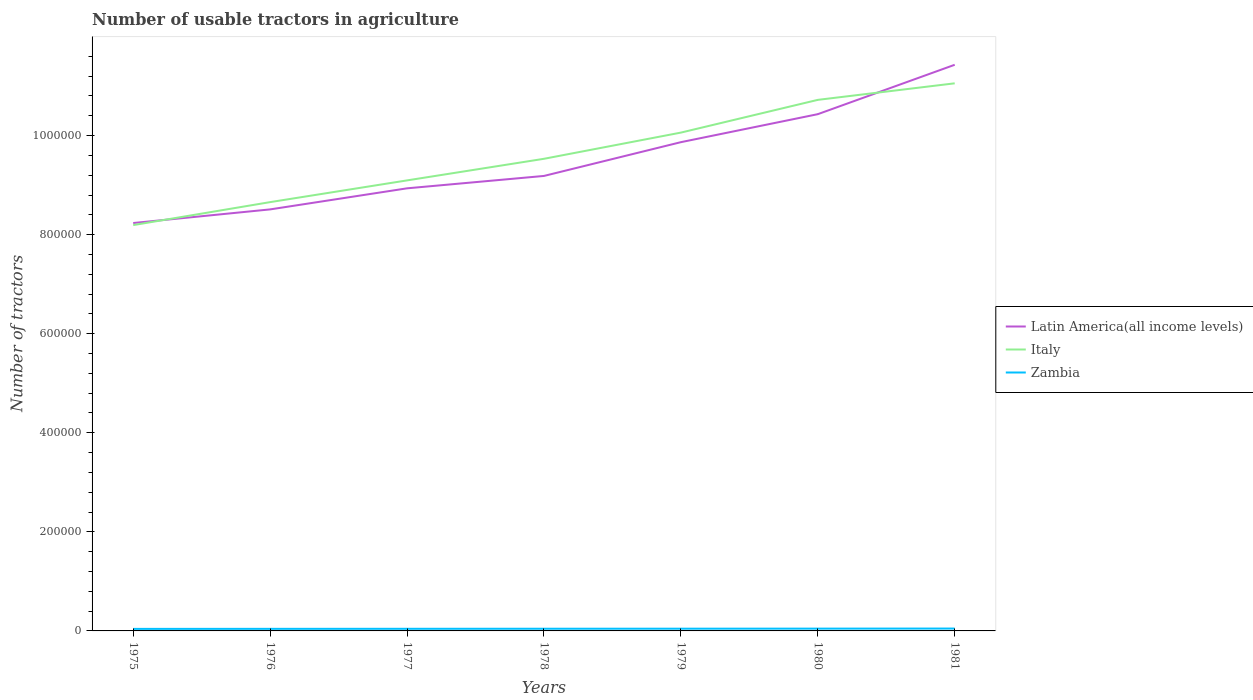Is the number of lines equal to the number of legend labels?
Your response must be concise. Yes. Across all years, what is the maximum number of usable tractors in agriculture in Zambia?
Offer a very short reply. 4100. In which year was the number of usable tractors in agriculture in Italy maximum?
Keep it short and to the point. 1975. What is the total number of usable tractors in agriculture in Italy in the graph?
Your answer should be very brief. -8.75e+04. What is the difference between the highest and the second highest number of usable tractors in agriculture in Latin America(all income levels)?
Make the answer very short. 3.19e+05. How many lines are there?
Your response must be concise. 3. How many years are there in the graph?
Your answer should be very brief. 7. What is the difference between two consecutive major ticks on the Y-axis?
Ensure brevity in your answer.  2.00e+05. Does the graph contain any zero values?
Your response must be concise. No. Does the graph contain grids?
Make the answer very short. No. Where does the legend appear in the graph?
Make the answer very short. Center right. How are the legend labels stacked?
Your answer should be compact. Vertical. What is the title of the graph?
Ensure brevity in your answer.  Number of usable tractors in agriculture. What is the label or title of the X-axis?
Keep it short and to the point. Years. What is the label or title of the Y-axis?
Ensure brevity in your answer.  Number of tractors. What is the Number of tractors in Latin America(all income levels) in 1975?
Offer a very short reply. 8.24e+05. What is the Number of tractors in Italy in 1975?
Offer a terse response. 8.19e+05. What is the Number of tractors in Zambia in 1975?
Your answer should be compact. 4100. What is the Number of tractors in Latin America(all income levels) in 1976?
Give a very brief answer. 8.51e+05. What is the Number of tractors in Italy in 1976?
Your answer should be compact. 8.66e+05. What is the Number of tractors in Zambia in 1976?
Your response must be concise. 4200. What is the Number of tractors in Latin America(all income levels) in 1977?
Offer a very short reply. 8.94e+05. What is the Number of tractors in Italy in 1977?
Keep it short and to the point. 9.10e+05. What is the Number of tractors of Zambia in 1977?
Ensure brevity in your answer.  4300. What is the Number of tractors in Latin America(all income levels) in 1978?
Make the answer very short. 9.19e+05. What is the Number of tractors of Italy in 1978?
Give a very brief answer. 9.53e+05. What is the Number of tractors in Zambia in 1978?
Your response must be concise. 4400. What is the Number of tractors of Latin America(all income levels) in 1979?
Give a very brief answer. 9.87e+05. What is the Number of tractors in Italy in 1979?
Make the answer very short. 1.01e+06. What is the Number of tractors of Zambia in 1979?
Give a very brief answer. 4500. What is the Number of tractors in Latin America(all income levels) in 1980?
Give a very brief answer. 1.04e+06. What is the Number of tractors of Italy in 1980?
Your response must be concise. 1.07e+06. What is the Number of tractors of Zambia in 1980?
Keep it short and to the point. 4640. What is the Number of tractors of Latin America(all income levels) in 1981?
Offer a very short reply. 1.14e+06. What is the Number of tractors of Italy in 1981?
Offer a very short reply. 1.11e+06. What is the Number of tractors of Zambia in 1981?
Your answer should be compact. 4780. Across all years, what is the maximum Number of tractors of Latin America(all income levels)?
Provide a short and direct response. 1.14e+06. Across all years, what is the maximum Number of tractors in Italy?
Keep it short and to the point. 1.11e+06. Across all years, what is the maximum Number of tractors in Zambia?
Your response must be concise. 4780. Across all years, what is the minimum Number of tractors in Latin America(all income levels)?
Your answer should be compact. 8.24e+05. Across all years, what is the minimum Number of tractors of Italy?
Offer a very short reply. 8.19e+05. Across all years, what is the minimum Number of tractors in Zambia?
Provide a succinct answer. 4100. What is the total Number of tractors of Latin America(all income levels) in the graph?
Ensure brevity in your answer.  6.66e+06. What is the total Number of tractors in Italy in the graph?
Offer a very short reply. 6.73e+06. What is the total Number of tractors in Zambia in the graph?
Ensure brevity in your answer.  3.09e+04. What is the difference between the Number of tractors in Latin America(all income levels) in 1975 and that in 1976?
Your answer should be compact. -2.75e+04. What is the difference between the Number of tractors in Italy in 1975 and that in 1976?
Provide a succinct answer. -4.64e+04. What is the difference between the Number of tractors in Zambia in 1975 and that in 1976?
Your response must be concise. -100. What is the difference between the Number of tractors in Latin America(all income levels) in 1975 and that in 1977?
Offer a very short reply. -7.01e+04. What is the difference between the Number of tractors in Italy in 1975 and that in 1977?
Give a very brief answer. -9.02e+04. What is the difference between the Number of tractors in Zambia in 1975 and that in 1977?
Offer a very short reply. -200. What is the difference between the Number of tractors in Latin America(all income levels) in 1975 and that in 1978?
Your answer should be compact. -9.51e+04. What is the difference between the Number of tractors in Italy in 1975 and that in 1978?
Offer a very short reply. -1.34e+05. What is the difference between the Number of tractors in Zambia in 1975 and that in 1978?
Provide a short and direct response. -300. What is the difference between the Number of tractors of Latin America(all income levels) in 1975 and that in 1979?
Keep it short and to the point. -1.63e+05. What is the difference between the Number of tractors in Italy in 1975 and that in 1979?
Provide a succinct answer. -1.87e+05. What is the difference between the Number of tractors of Zambia in 1975 and that in 1979?
Keep it short and to the point. -400. What is the difference between the Number of tractors of Latin America(all income levels) in 1975 and that in 1980?
Offer a terse response. -2.20e+05. What is the difference between the Number of tractors in Italy in 1975 and that in 1980?
Give a very brief answer. -2.53e+05. What is the difference between the Number of tractors of Zambia in 1975 and that in 1980?
Provide a short and direct response. -540. What is the difference between the Number of tractors of Latin America(all income levels) in 1975 and that in 1981?
Give a very brief answer. -3.19e+05. What is the difference between the Number of tractors of Italy in 1975 and that in 1981?
Make the answer very short. -2.86e+05. What is the difference between the Number of tractors of Zambia in 1975 and that in 1981?
Offer a very short reply. -680. What is the difference between the Number of tractors of Latin America(all income levels) in 1976 and that in 1977?
Ensure brevity in your answer.  -4.25e+04. What is the difference between the Number of tractors of Italy in 1976 and that in 1977?
Your answer should be very brief. -4.39e+04. What is the difference between the Number of tractors of Zambia in 1976 and that in 1977?
Offer a terse response. -100. What is the difference between the Number of tractors of Latin America(all income levels) in 1976 and that in 1978?
Provide a short and direct response. -6.76e+04. What is the difference between the Number of tractors of Italy in 1976 and that in 1978?
Ensure brevity in your answer.  -8.75e+04. What is the difference between the Number of tractors in Zambia in 1976 and that in 1978?
Your answer should be compact. -200. What is the difference between the Number of tractors in Latin America(all income levels) in 1976 and that in 1979?
Give a very brief answer. -1.36e+05. What is the difference between the Number of tractors of Italy in 1976 and that in 1979?
Provide a short and direct response. -1.40e+05. What is the difference between the Number of tractors of Zambia in 1976 and that in 1979?
Provide a short and direct response. -300. What is the difference between the Number of tractors of Latin America(all income levels) in 1976 and that in 1980?
Offer a very short reply. -1.92e+05. What is the difference between the Number of tractors of Italy in 1976 and that in 1980?
Your answer should be very brief. -2.06e+05. What is the difference between the Number of tractors in Zambia in 1976 and that in 1980?
Give a very brief answer. -440. What is the difference between the Number of tractors in Latin America(all income levels) in 1976 and that in 1981?
Give a very brief answer. -2.92e+05. What is the difference between the Number of tractors in Italy in 1976 and that in 1981?
Make the answer very short. -2.40e+05. What is the difference between the Number of tractors in Zambia in 1976 and that in 1981?
Keep it short and to the point. -580. What is the difference between the Number of tractors in Latin America(all income levels) in 1977 and that in 1978?
Offer a terse response. -2.50e+04. What is the difference between the Number of tractors in Italy in 1977 and that in 1978?
Offer a very short reply. -4.36e+04. What is the difference between the Number of tractors in Zambia in 1977 and that in 1978?
Offer a very short reply. -100. What is the difference between the Number of tractors in Latin America(all income levels) in 1977 and that in 1979?
Offer a terse response. -9.32e+04. What is the difference between the Number of tractors in Italy in 1977 and that in 1979?
Provide a succinct answer. -9.65e+04. What is the difference between the Number of tractors of Zambia in 1977 and that in 1979?
Your answer should be compact. -200. What is the difference between the Number of tractors in Latin America(all income levels) in 1977 and that in 1980?
Your response must be concise. -1.50e+05. What is the difference between the Number of tractors in Italy in 1977 and that in 1980?
Your answer should be very brief. -1.63e+05. What is the difference between the Number of tractors of Zambia in 1977 and that in 1980?
Offer a terse response. -340. What is the difference between the Number of tractors in Latin America(all income levels) in 1977 and that in 1981?
Keep it short and to the point. -2.49e+05. What is the difference between the Number of tractors in Italy in 1977 and that in 1981?
Your response must be concise. -1.96e+05. What is the difference between the Number of tractors of Zambia in 1977 and that in 1981?
Offer a terse response. -480. What is the difference between the Number of tractors in Latin America(all income levels) in 1978 and that in 1979?
Your response must be concise. -6.82e+04. What is the difference between the Number of tractors in Italy in 1978 and that in 1979?
Your answer should be very brief. -5.29e+04. What is the difference between the Number of tractors of Zambia in 1978 and that in 1979?
Your response must be concise. -100. What is the difference between the Number of tractors of Latin America(all income levels) in 1978 and that in 1980?
Keep it short and to the point. -1.25e+05. What is the difference between the Number of tractors of Italy in 1978 and that in 1980?
Give a very brief answer. -1.19e+05. What is the difference between the Number of tractors in Zambia in 1978 and that in 1980?
Offer a terse response. -240. What is the difference between the Number of tractors of Latin America(all income levels) in 1978 and that in 1981?
Your answer should be compact. -2.24e+05. What is the difference between the Number of tractors of Italy in 1978 and that in 1981?
Offer a very short reply. -1.52e+05. What is the difference between the Number of tractors of Zambia in 1978 and that in 1981?
Offer a very short reply. -380. What is the difference between the Number of tractors of Latin America(all income levels) in 1979 and that in 1980?
Your response must be concise. -5.65e+04. What is the difference between the Number of tractors in Italy in 1979 and that in 1980?
Your response must be concise. -6.61e+04. What is the difference between the Number of tractors in Zambia in 1979 and that in 1980?
Your response must be concise. -140. What is the difference between the Number of tractors of Latin America(all income levels) in 1979 and that in 1981?
Ensure brevity in your answer.  -1.56e+05. What is the difference between the Number of tractors of Italy in 1979 and that in 1981?
Offer a very short reply. -9.95e+04. What is the difference between the Number of tractors in Zambia in 1979 and that in 1981?
Offer a terse response. -280. What is the difference between the Number of tractors of Latin America(all income levels) in 1980 and that in 1981?
Make the answer very short. -9.97e+04. What is the difference between the Number of tractors of Italy in 1980 and that in 1981?
Keep it short and to the point. -3.34e+04. What is the difference between the Number of tractors in Zambia in 1980 and that in 1981?
Your response must be concise. -140. What is the difference between the Number of tractors of Latin America(all income levels) in 1975 and the Number of tractors of Italy in 1976?
Keep it short and to the point. -4.22e+04. What is the difference between the Number of tractors of Latin America(all income levels) in 1975 and the Number of tractors of Zambia in 1976?
Provide a short and direct response. 8.19e+05. What is the difference between the Number of tractors in Italy in 1975 and the Number of tractors in Zambia in 1976?
Keep it short and to the point. 8.15e+05. What is the difference between the Number of tractors in Latin America(all income levels) in 1975 and the Number of tractors in Italy in 1977?
Provide a short and direct response. -8.61e+04. What is the difference between the Number of tractors of Latin America(all income levels) in 1975 and the Number of tractors of Zambia in 1977?
Keep it short and to the point. 8.19e+05. What is the difference between the Number of tractors of Italy in 1975 and the Number of tractors of Zambia in 1977?
Ensure brevity in your answer.  8.15e+05. What is the difference between the Number of tractors in Latin America(all income levels) in 1975 and the Number of tractors in Italy in 1978?
Offer a terse response. -1.30e+05. What is the difference between the Number of tractors of Latin America(all income levels) in 1975 and the Number of tractors of Zambia in 1978?
Make the answer very short. 8.19e+05. What is the difference between the Number of tractors in Italy in 1975 and the Number of tractors in Zambia in 1978?
Offer a very short reply. 8.15e+05. What is the difference between the Number of tractors in Latin America(all income levels) in 1975 and the Number of tractors in Italy in 1979?
Offer a very short reply. -1.83e+05. What is the difference between the Number of tractors in Latin America(all income levels) in 1975 and the Number of tractors in Zambia in 1979?
Your answer should be very brief. 8.19e+05. What is the difference between the Number of tractors of Italy in 1975 and the Number of tractors of Zambia in 1979?
Offer a terse response. 8.15e+05. What is the difference between the Number of tractors of Latin America(all income levels) in 1975 and the Number of tractors of Italy in 1980?
Offer a terse response. -2.49e+05. What is the difference between the Number of tractors in Latin America(all income levels) in 1975 and the Number of tractors in Zambia in 1980?
Keep it short and to the point. 8.19e+05. What is the difference between the Number of tractors in Italy in 1975 and the Number of tractors in Zambia in 1980?
Offer a terse response. 8.15e+05. What is the difference between the Number of tractors in Latin America(all income levels) in 1975 and the Number of tractors in Italy in 1981?
Provide a short and direct response. -2.82e+05. What is the difference between the Number of tractors in Latin America(all income levels) in 1975 and the Number of tractors in Zambia in 1981?
Provide a short and direct response. 8.19e+05. What is the difference between the Number of tractors of Italy in 1975 and the Number of tractors of Zambia in 1981?
Keep it short and to the point. 8.15e+05. What is the difference between the Number of tractors in Latin America(all income levels) in 1976 and the Number of tractors in Italy in 1977?
Your response must be concise. -5.85e+04. What is the difference between the Number of tractors of Latin America(all income levels) in 1976 and the Number of tractors of Zambia in 1977?
Keep it short and to the point. 8.47e+05. What is the difference between the Number of tractors in Italy in 1976 and the Number of tractors in Zambia in 1977?
Provide a succinct answer. 8.61e+05. What is the difference between the Number of tractors in Latin America(all income levels) in 1976 and the Number of tractors in Italy in 1978?
Your response must be concise. -1.02e+05. What is the difference between the Number of tractors of Latin America(all income levels) in 1976 and the Number of tractors of Zambia in 1978?
Give a very brief answer. 8.47e+05. What is the difference between the Number of tractors of Italy in 1976 and the Number of tractors of Zambia in 1978?
Make the answer very short. 8.61e+05. What is the difference between the Number of tractors of Latin America(all income levels) in 1976 and the Number of tractors of Italy in 1979?
Provide a short and direct response. -1.55e+05. What is the difference between the Number of tractors of Latin America(all income levels) in 1976 and the Number of tractors of Zambia in 1979?
Ensure brevity in your answer.  8.47e+05. What is the difference between the Number of tractors in Italy in 1976 and the Number of tractors in Zambia in 1979?
Offer a very short reply. 8.61e+05. What is the difference between the Number of tractors in Latin America(all income levels) in 1976 and the Number of tractors in Italy in 1980?
Keep it short and to the point. -2.21e+05. What is the difference between the Number of tractors in Latin America(all income levels) in 1976 and the Number of tractors in Zambia in 1980?
Give a very brief answer. 8.46e+05. What is the difference between the Number of tractors of Italy in 1976 and the Number of tractors of Zambia in 1980?
Make the answer very short. 8.61e+05. What is the difference between the Number of tractors in Latin America(all income levels) in 1976 and the Number of tractors in Italy in 1981?
Your response must be concise. -2.55e+05. What is the difference between the Number of tractors in Latin America(all income levels) in 1976 and the Number of tractors in Zambia in 1981?
Your answer should be very brief. 8.46e+05. What is the difference between the Number of tractors in Italy in 1976 and the Number of tractors in Zambia in 1981?
Provide a short and direct response. 8.61e+05. What is the difference between the Number of tractors in Latin America(all income levels) in 1977 and the Number of tractors in Italy in 1978?
Make the answer very short. -5.96e+04. What is the difference between the Number of tractors of Latin America(all income levels) in 1977 and the Number of tractors of Zambia in 1978?
Your answer should be very brief. 8.89e+05. What is the difference between the Number of tractors of Italy in 1977 and the Number of tractors of Zambia in 1978?
Keep it short and to the point. 9.05e+05. What is the difference between the Number of tractors of Latin America(all income levels) in 1977 and the Number of tractors of Italy in 1979?
Give a very brief answer. -1.13e+05. What is the difference between the Number of tractors in Latin America(all income levels) in 1977 and the Number of tractors in Zambia in 1979?
Give a very brief answer. 8.89e+05. What is the difference between the Number of tractors in Italy in 1977 and the Number of tractors in Zambia in 1979?
Ensure brevity in your answer.  9.05e+05. What is the difference between the Number of tractors in Latin America(all income levels) in 1977 and the Number of tractors in Italy in 1980?
Keep it short and to the point. -1.79e+05. What is the difference between the Number of tractors of Latin America(all income levels) in 1977 and the Number of tractors of Zambia in 1980?
Your answer should be very brief. 8.89e+05. What is the difference between the Number of tractors of Italy in 1977 and the Number of tractors of Zambia in 1980?
Ensure brevity in your answer.  9.05e+05. What is the difference between the Number of tractors of Latin America(all income levels) in 1977 and the Number of tractors of Italy in 1981?
Provide a short and direct response. -2.12e+05. What is the difference between the Number of tractors in Latin America(all income levels) in 1977 and the Number of tractors in Zambia in 1981?
Your answer should be compact. 8.89e+05. What is the difference between the Number of tractors of Italy in 1977 and the Number of tractors of Zambia in 1981?
Keep it short and to the point. 9.05e+05. What is the difference between the Number of tractors of Latin America(all income levels) in 1978 and the Number of tractors of Italy in 1979?
Provide a short and direct response. -8.75e+04. What is the difference between the Number of tractors of Latin America(all income levels) in 1978 and the Number of tractors of Zambia in 1979?
Your answer should be compact. 9.14e+05. What is the difference between the Number of tractors in Italy in 1978 and the Number of tractors in Zambia in 1979?
Provide a short and direct response. 9.49e+05. What is the difference between the Number of tractors of Latin America(all income levels) in 1978 and the Number of tractors of Italy in 1980?
Your answer should be compact. -1.54e+05. What is the difference between the Number of tractors of Latin America(all income levels) in 1978 and the Number of tractors of Zambia in 1980?
Your answer should be compact. 9.14e+05. What is the difference between the Number of tractors of Italy in 1978 and the Number of tractors of Zambia in 1980?
Ensure brevity in your answer.  9.49e+05. What is the difference between the Number of tractors of Latin America(all income levels) in 1978 and the Number of tractors of Italy in 1981?
Give a very brief answer. -1.87e+05. What is the difference between the Number of tractors in Latin America(all income levels) in 1978 and the Number of tractors in Zambia in 1981?
Offer a terse response. 9.14e+05. What is the difference between the Number of tractors of Italy in 1978 and the Number of tractors of Zambia in 1981?
Your answer should be compact. 9.48e+05. What is the difference between the Number of tractors of Latin America(all income levels) in 1979 and the Number of tractors of Italy in 1980?
Your response must be concise. -8.54e+04. What is the difference between the Number of tractors in Latin America(all income levels) in 1979 and the Number of tractors in Zambia in 1980?
Keep it short and to the point. 9.82e+05. What is the difference between the Number of tractors in Italy in 1979 and the Number of tractors in Zambia in 1980?
Make the answer very short. 1.00e+06. What is the difference between the Number of tractors of Latin America(all income levels) in 1979 and the Number of tractors of Italy in 1981?
Ensure brevity in your answer.  -1.19e+05. What is the difference between the Number of tractors in Latin America(all income levels) in 1979 and the Number of tractors in Zambia in 1981?
Provide a short and direct response. 9.82e+05. What is the difference between the Number of tractors in Italy in 1979 and the Number of tractors in Zambia in 1981?
Make the answer very short. 1.00e+06. What is the difference between the Number of tractors of Latin America(all income levels) in 1980 and the Number of tractors of Italy in 1981?
Offer a very short reply. -6.23e+04. What is the difference between the Number of tractors in Latin America(all income levels) in 1980 and the Number of tractors in Zambia in 1981?
Offer a terse response. 1.04e+06. What is the difference between the Number of tractors of Italy in 1980 and the Number of tractors of Zambia in 1981?
Offer a very short reply. 1.07e+06. What is the average Number of tractors of Latin America(all income levels) per year?
Your answer should be very brief. 9.51e+05. What is the average Number of tractors in Italy per year?
Your answer should be compact. 9.62e+05. What is the average Number of tractors of Zambia per year?
Offer a terse response. 4417.14. In the year 1975, what is the difference between the Number of tractors in Latin America(all income levels) and Number of tractors in Italy?
Offer a terse response. 4179. In the year 1975, what is the difference between the Number of tractors in Latin America(all income levels) and Number of tractors in Zambia?
Your response must be concise. 8.19e+05. In the year 1975, what is the difference between the Number of tractors of Italy and Number of tractors of Zambia?
Ensure brevity in your answer.  8.15e+05. In the year 1976, what is the difference between the Number of tractors in Latin America(all income levels) and Number of tractors in Italy?
Offer a very short reply. -1.47e+04. In the year 1976, what is the difference between the Number of tractors in Latin America(all income levels) and Number of tractors in Zambia?
Make the answer very short. 8.47e+05. In the year 1976, what is the difference between the Number of tractors of Italy and Number of tractors of Zambia?
Give a very brief answer. 8.62e+05. In the year 1977, what is the difference between the Number of tractors in Latin America(all income levels) and Number of tractors in Italy?
Your answer should be very brief. -1.60e+04. In the year 1977, what is the difference between the Number of tractors in Latin America(all income levels) and Number of tractors in Zambia?
Your answer should be very brief. 8.89e+05. In the year 1977, what is the difference between the Number of tractors in Italy and Number of tractors in Zambia?
Provide a succinct answer. 9.05e+05. In the year 1978, what is the difference between the Number of tractors in Latin America(all income levels) and Number of tractors in Italy?
Ensure brevity in your answer.  -3.46e+04. In the year 1978, what is the difference between the Number of tractors of Latin America(all income levels) and Number of tractors of Zambia?
Provide a short and direct response. 9.14e+05. In the year 1978, what is the difference between the Number of tractors of Italy and Number of tractors of Zambia?
Provide a short and direct response. 9.49e+05. In the year 1979, what is the difference between the Number of tractors in Latin America(all income levels) and Number of tractors in Italy?
Provide a short and direct response. -1.93e+04. In the year 1979, what is the difference between the Number of tractors of Latin America(all income levels) and Number of tractors of Zambia?
Offer a terse response. 9.82e+05. In the year 1979, what is the difference between the Number of tractors in Italy and Number of tractors in Zambia?
Offer a terse response. 1.00e+06. In the year 1980, what is the difference between the Number of tractors in Latin America(all income levels) and Number of tractors in Italy?
Offer a very short reply. -2.89e+04. In the year 1980, what is the difference between the Number of tractors in Latin America(all income levels) and Number of tractors in Zambia?
Keep it short and to the point. 1.04e+06. In the year 1980, what is the difference between the Number of tractors in Italy and Number of tractors in Zambia?
Offer a terse response. 1.07e+06. In the year 1981, what is the difference between the Number of tractors in Latin America(all income levels) and Number of tractors in Italy?
Provide a short and direct response. 3.74e+04. In the year 1981, what is the difference between the Number of tractors in Latin America(all income levels) and Number of tractors in Zambia?
Ensure brevity in your answer.  1.14e+06. In the year 1981, what is the difference between the Number of tractors of Italy and Number of tractors of Zambia?
Your answer should be compact. 1.10e+06. What is the ratio of the Number of tractors in Italy in 1975 to that in 1976?
Ensure brevity in your answer.  0.95. What is the ratio of the Number of tractors of Zambia in 1975 to that in 1976?
Your answer should be compact. 0.98. What is the ratio of the Number of tractors of Latin America(all income levels) in 1975 to that in 1977?
Ensure brevity in your answer.  0.92. What is the ratio of the Number of tractors of Italy in 1975 to that in 1977?
Your answer should be very brief. 0.9. What is the ratio of the Number of tractors in Zambia in 1975 to that in 1977?
Give a very brief answer. 0.95. What is the ratio of the Number of tractors of Latin America(all income levels) in 1975 to that in 1978?
Give a very brief answer. 0.9. What is the ratio of the Number of tractors of Italy in 1975 to that in 1978?
Make the answer very short. 0.86. What is the ratio of the Number of tractors in Zambia in 1975 to that in 1978?
Offer a terse response. 0.93. What is the ratio of the Number of tractors in Latin America(all income levels) in 1975 to that in 1979?
Provide a succinct answer. 0.83. What is the ratio of the Number of tractors of Italy in 1975 to that in 1979?
Keep it short and to the point. 0.81. What is the ratio of the Number of tractors of Zambia in 1975 to that in 1979?
Give a very brief answer. 0.91. What is the ratio of the Number of tractors of Latin America(all income levels) in 1975 to that in 1980?
Your answer should be compact. 0.79. What is the ratio of the Number of tractors of Italy in 1975 to that in 1980?
Make the answer very short. 0.76. What is the ratio of the Number of tractors in Zambia in 1975 to that in 1980?
Your response must be concise. 0.88. What is the ratio of the Number of tractors in Latin America(all income levels) in 1975 to that in 1981?
Your response must be concise. 0.72. What is the ratio of the Number of tractors of Italy in 1975 to that in 1981?
Provide a short and direct response. 0.74. What is the ratio of the Number of tractors of Zambia in 1975 to that in 1981?
Provide a succinct answer. 0.86. What is the ratio of the Number of tractors in Latin America(all income levels) in 1976 to that in 1977?
Keep it short and to the point. 0.95. What is the ratio of the Number of tractors of Italy in 1976 to that in 1977?
Provide a short and direct response. 0.95. What is the ratio of the Number of tractors in Zambia in 1976 to that in 1977?
Your answer should be compact. 0.98. What is the ratio of the Number of tractors in Latin America(all income levels) in 1976 to that in 1978?
Offer a very short reply. 0.93. What is the ratio of the Number of tractors in Italy in 1976 to that in 1978?
Offer a very short reply. 0.91. What is the ratio of the Number of tractors of Zambia in 1976 to that in 1978?
Offer a very short reply. 0.95. What is the ratio of the Number of tractors in Latin America(all income levels) in 1976 to that in 1979?
Provide a succinct answer. 0.86. What is the ratio of the Number of tractors of Italy in 1976 to that in 1979?
Provide a succinct answer. 0.86. What is the ratio of the Number of tractors in Zambia in 1976 to that in 1979?
Keep it short and to the point. 0.93. What is the ratio of the Number of tractors in Latin America(all income levels) in 1976 to that in 1980?
Your answer should be very brief. 0.82. What is the ratio of the Number of tractors of Italy in 1976 to that in 1980?
Provide a short and direct response. 0.81. What is the ratio of the Number of tractors in Zambia in 1976 to that in 1980?
Your answer should be very brief. 0.91. What is the ratio of the Number of tractors in Latin America(all income levels) in 1976 to that in 1981?
Give a very brief answer. 0.74. What is the ratio of the Number of tractors of Italy in 1976 to that in 1981?
Offer a very short reply. 0.78. What is the ratio of the Number of tractors in Zambia in 1976 to that in 1981?
Your answer should be very brief. 0.88. What is the ratio of the Number of tractors in Latin America(all income levels) in 1977 to that in 1978?
Your answer should be compact. 0.97. What is the ratio of the Number of tractors in Italy in 1977 to that in 1978?
Your answer should be very brief. 0.95. What is the ratio of the Number of tractors of Zambia in 1977 to that in 1978?
Your response must be concise. 0.98. What is the ratio of the Number of tractors in Latin America(all income levels) in 1977 to that in 1979?
Ensure brevity in your answer.  0.91. What is the ratio of the Number of tractors in Italy in 1977 to that in 1979?
Your answer should be compact. 0.9. What is the ratio of the Number of tractors of Zambia in 1977 to that in 1979?
Ensure brevity in your answer.  0.96. What is the ratio of the Number of tractors in Latin America(all income levels) in 1977 to that in 1980?
Offer a terse response. 0.86. What is the ratio of the Number of tractors in Italy in 1977 to that in 1980?
Your answer should be very brief. 0.85. What is the ratio of the Number of tractors in Zambia in 1977 to that in 1980?
Provide a short and direct response. 0.93. What is the ratio of the Number of tractors of Latin America(all income levels) in 1977 to that in 1981?
Your response must be concise. 0.78. What is the ratio of the Number of tractors in Italy in 1977 to that in 1981?
Give a very brief answer. 0.82. What is the ratio of the Number of tractors of Zambia in 1977 to that in 1981?
Give a very brief answer. 0.9. What is the ratio of the Number of tractors of Latin America(all income levels) in 1978 to that in 1979?
Keep it short and to the point. 0.93. What is the ratio of the Number of tractors of Italy in 1978 to that in 1979?
Make the answer very short. 0.95. What is the ratio of the Number of tractors of Zambia in 1978 to that in 1979?
Your response must be concise. 0.98. What is the ratio of the Number of tractors of Latin America(all income levels) in 1978 to that in 1980?
Make the answer very short. 0.88. What is the ratio of the Number of tractors of Italy in 1978 to that in 1980?
Provide a succinct answer. 0.89. What is the ratio of the Number of tractors of Zambia in 1978 to that in 1980?
Make the answer very short. 0.95. What is the ratio of the Number of tractors in Latin America(all income levels) in 1978 to that in 1981?
Ensure brevity in your answer.  0.8. What is the ratio of the Number of tractors of Italy in 1978 to that in 1981?
Provide a short and direct response. 0.86. What is the ratio of the Number of tractors of Zambia in 1978 to that in 1981?
Provide a short and direct response. 0.92. What is the ratio of the Number of tractors in Latin America(all income levels) in 1979 to that in 1980?
Provide a succinct answer. 0.95. What is the ratio of the Number of tractors of Italy in 1979 to that in 1980?
Your answer should be compact. 0.94. What is the ratio of the Number of tractors in Zambia in 1979 to that in 1980?
Your response must be concise. 0.97. What is the ratio of the Number of tractors of Latin America(all income levels) in 1979 to that in 1981?
Ensure brevity in your answer.  0.86. What is the ratio of the Number of tractors of Italy in 1979 to that in 1981?
Ensure brevity in your answer.  0.91. What is the ratio of the Number of tractors in Zambia in 1979 to that in 1981?
Provide a succinct answer. 0.94. What is the ratio of the Number of tractors in Latin America(all income levels) in 1980 to that in 1981?
Provide a succinct answer. 0.91. What is the ratio of the Number of tractors of Italy in 1980 to that in 1981?
Give a very brief answer. 0.97. What is the ratio of the Number of tractors in Zambia in 1980 to that in 1981?
Provide a succinct answer. 0.97. What is the difference between the highest and the second highest Number of tractors in Latin America(all income levels)?
Offer a terse response. 9.97e+04. What is the difference between the highest and the second highest Number of tractors in Italy?
Your answer should be compact. 3.34e+04. What is the difference between the highest and the second highest Number of tractors of Zambia?
Your answer should be compact. 140. What is the difference between the highest and the lowest Number of tractors of Latin America(all income levels)?
Keep it short and to the point. 3.19e+05. What is the difference between the highest and the lowest Number of tractors in Italy?
Provide a short and direct response. 2.86e+05. What is the difference between the highest and the lowest Number of tractors in Zambia?
Offer a terse response. 680. 